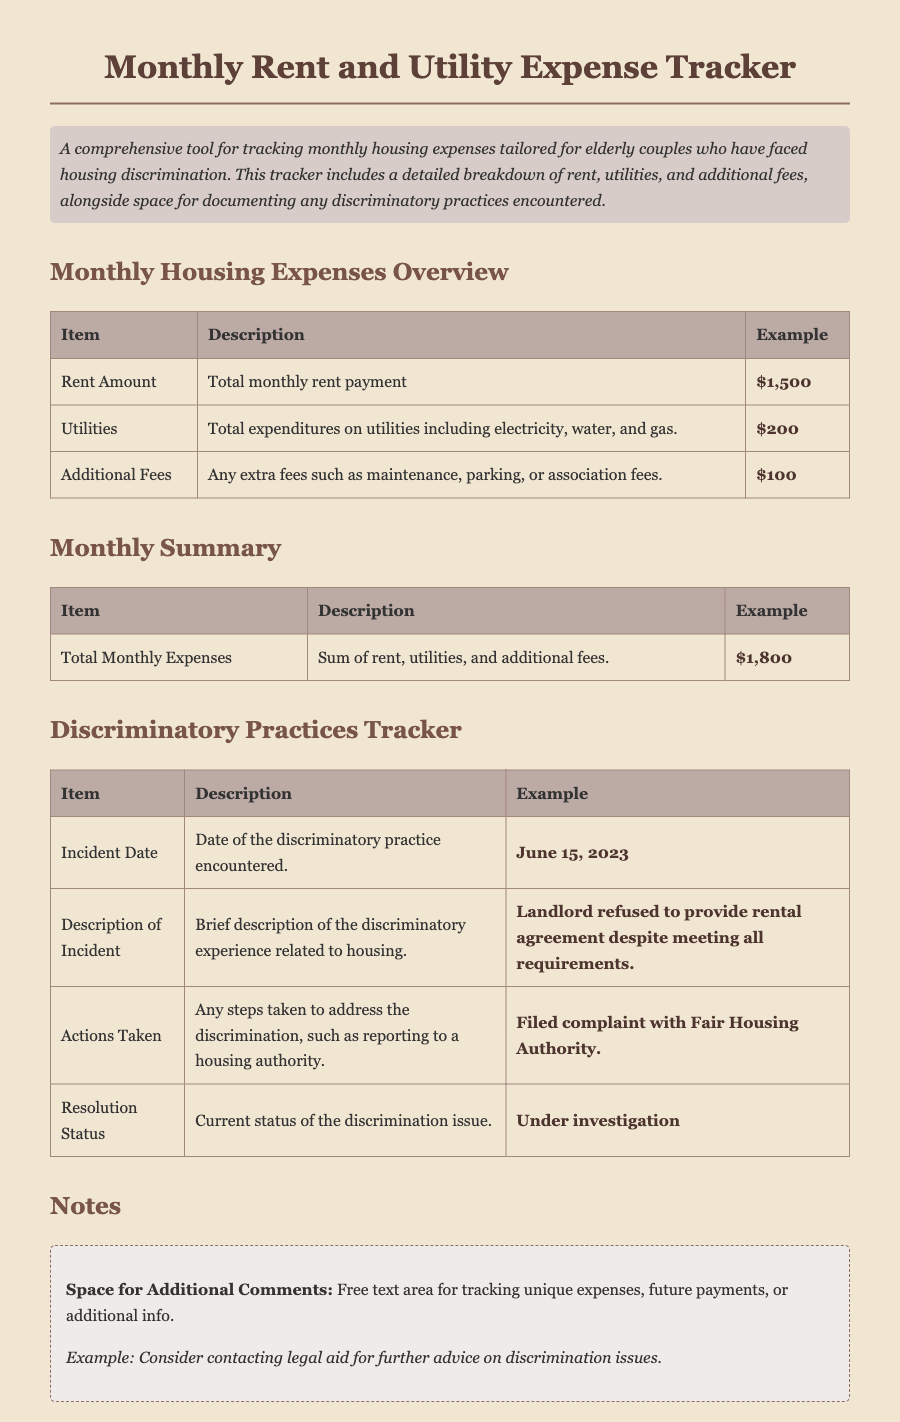what is the total monthly rent payment? The total monthly rent payment is listed as the Rent Amount in the document.
Answer: $1,500 what types of utilities are included in the tracker? The utilities are described as including electricity, water, and gas, which are specified in the Utilities section.
Answer: Electricity, water, gas what is the total monthly expense including all fees? The total monthly expenses is the sum of rent, utilities, and additional fees, shown in the Monthly Summary section.
Answer: $1,800 when was the incident of discrimination recorded? The Incident Date is provided in the Discriminatory Practices Tracker section.
Answer: June 15, 2023 what actions were taken to address the discrimination? The Actions Taken section outlines the steps taken in response to the discrimination, according to the document.
Answer: Filed complaint with Fair Housing Authority what is the current status of the discrimination issue? The Resolution Status indicates the current situation of the discrimination issue documented.
Answer: Under investigation which section includes space for notes? The Notes section provides space for additional comments and notes related to any expenses or discrimination issues.
Answer: Notes what is the description of the additional fees? The Additional Fees section outlines the types of extra fees that may be included in the tracker, which are described in that table.
Answer: Maintenance, parking, association fees 